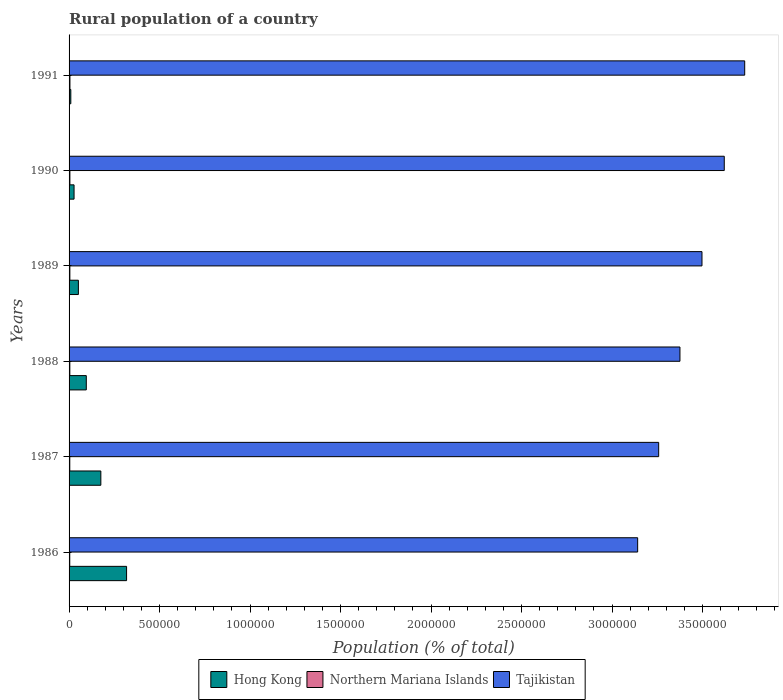Are the number of bars per tick equal to the number of legend labels?
Provide a short and direct response. Yes. How many bars are there on the 4th tick from the top?
Offer a very short reply. 3. How many bars are there on the 6th tick from the bottom?
Your response must be concise. 3. In how many cases, is the number of bars for a given year not equal to the number of legend labels?
Offer a very short reply. 0. What is the rural population in Tajikistan in 1989?
Your answer should be very brief. 3.50e+06. Across all years, what is the maximum rural population in Tajikistan?
Give a very brief answer. 3.73e+06. Across all years, what is the minimum rural population in Hong Kong?
Your answer should be very brief. 9663. In which year was the rural population in Hong Kong minimum?
Your answer should be very brief. 1991. What is the total rural population in Tajikistan in the graph?
Your answer should be very brief. 2.06e+07. What is the difference between the rural population in Tajikistan in 1986 and that in 1988?
Ensure brevity in your answer.  -2.34e+05. What is the difference between the rural population in Northern Mariana Islands in 1990 and the rural population in Tajikistan in 1988?
Your answer should be compact. -3.37e+06. What is the average rural population in Northern Mariana Islands per year?
Your response must be concise. 4250.67. In the year 1989, what is the difference between the rural population in Tajikistan and rural population in Northern Mariana Islands?
Your answer should be very brief. 3.49e+06. What is the ratio of the rural population in Hong Kong in 1988 to that in 1990?
Offer a terse response. 3.45. Is the difference between the rural population in Tajikistan in 1986 and 1987 greater than the difference between the rural population in Northern Mariana Islands in 1986 and 1987?
Your answer should be compact. No. What is the difference between the highest and the second highest rural population in Hong Kong?
Your answer should be compact. 1.42e+05. What is the difference between the highest and the lowest rural population in Northern Mariana Islands?
Your response must be concise. 1057. In how many years, is the rural population in Hong Kong greater than the average rural population in Hong Kong taken over all years?
Provide a succinct answer. 2. Is the sum of the rural population in Hong Kong in 1988 and 1990 greater than the maximum rural population in Tajikistan across all years?
Your answer should be compact. No. What does the 2nd bar from the top in 1989 represents?
Offer a terse response. Northern Mariana Islands. What does the 1st bar from the bottom in 1990 represents?
Your response must be concise. Hong Kong. How many years are there in the graph?
Offer a very short reply. 6. What is the difference between two consecutive major ticks on the X-axis?
Provide a short and direct response. 5.00e+05. Are the values on the major ticks of X-axis written in scientific E-notation?
Keep it short and to the point. No. Does the graph contain any zero values?
Ensure brevity in your answer.  No. Does the graph contain grids?
Your answer should be very brief. No. Where does the legend appear in the graph?
Provide a succinct answer. Bottom center. How are the legend labels stacked?
Ensure brevity in your answer.  Horizontal. What is the title of the graph?
Provide a succinct answer. Rural population of a country. What is the label or title of the X-axis?
Offer a very short reply. Population (% of total). What is the Population (% of total) in Hong Kong in 1986?
Give a very brief answer. 3.18e+05. What is the Population (% of total) of Northern Mariana Islands in 1986?
Your answer should be very brief. 3756. What is the Population (% of total) in Tajikistan in 1986?
Offer a terse response. 3.14e+06. What is the Population (% of total) in Hong Kong in 1987?
Your response must be concise. 1.76e+05. What is the Population (% of total) in Northern Mariana Islands in 1987?
Your response must be concise. 3960. What is the Population (% of total) in Tajikistan in 1987?
Provide a short and direct response. 3.26e+06. What is the Population (% of total) of Hong Kong in 1988?
Make the answer very short. 9.52e+04. What is the Population (% of total) of Northern Mariana Islands in 1988?
Your answer should be compact. 4144. What is the Population (% of total) of Tajikistan in 1988?
Keep it short and to the point. 3.38e+06. What is the Population (% of total) of Hong Kong in 1989?
Provide a short and direct response. 5.15e+04. What is the Population (% of total) in Northern Mariana Islands in 1989?
Give a very brief answer. 4316. What is the Population (% of total) of Tajikistan in 1989?
Keep it short and to the point. 3.50e+06. What is the Population (% of total) in Hong Kong in 1990?
Make the answer very short. 2.76e+04. What is the Population (% of total) of Northern Mariana Islands in 1990?
Provide a short and direct response. 4515. What is the Population (% of total) of Tajikistan in 1990?
Offer a terse response. 3.62e+06. What is the Population (% of total) of Hong Kong in 1991?
Provide a short and direct response. 9663. What is the Population (% of total) of Northern Mariana Islands in 1991?
Give a very brief answer. 4813. What is the Population (% of total) of Tajikistan in 1991?
Offer a terse response. 3.73e+06. Across all years, what is the maximum Population (% of total) in Hong Kong?
Keep it short and to the point. 3.18e+05. Across all years, what is the maximum Population (% of total) of Northern Mariana Islands?
Provide a succinct answer. 4813. Across all years, what is the maximum Population (% of total) in Tajikistan?
Provide a short and direct response. 3.73e+06. Across all years, what is the minimum Population (% of total) of Hong Kong?
Your answer should be very brief. 9663. Across all years, what is the minimum Population (% of total) of Northern Mariana Islands?
Offer a very short reply. 3756. Across all years, what is the minimum Population (% of total) of Tajikistan?
Make the answer very short. 3.14e+06. What is the total Population (% of total) in Hong Kong in the graph?
Make the answer very short. 6.77e+05. What is the total Population (% of total) in Northern Mariana Islands in the graph?
Give a very brief answer. 2.55e+04. What is the total Population (% of total) in Tajikistan in the graph?
Provide a short and direct response. 2.06e+07. What is the difference between the Population (% of total) in Hong Kong in 1986 and that in 1987?
Provide a short and direct response. 1.42e+05. What is the difference between the Population (% of total) of Northern Mariana Islands in 1986 and that in 1987?
Your answer should be very brief. -204. What is the difference between the Population (% of total) in Tajikistan in 1986 and that in 1987?
Ensure brevity in your answer.  -1.16e+05. What is the difference between the Population (% of total) in Hong Kong in 1986 and that in 1988?
Offer a terse response. 2.23e+05. What is the difference between the Population (% of total) in Northern Mariana Islands in 1986 and that in 1988?
Offer a terse response. -388. What is the difference between the Population (% of total) in Tajikistan in 1986 and that in 1988?
Give a very brief answer. -2.34e+05. What is the difference between the Population (% of total) of Hong Kong in 1986 and that in 1989?
Offer a very short reply. 2.66e+05. What is the difference between the Population (% of total) in Northern Mariana Islands in 1986 and that in 1989?
Offer a terse response. -560. What is the difference between the Population (% of total) of Tajikistan in 1986 and that in 1989?
Offer a terse response. -3.55e+05. What is the difference between the Population (% of total) in Hong Kong in 1986 and that in 1990?
Make the answer very short. 2.90e+05. What is the difference between the Population (% of total) of Northern Mariana Islands in 1986 and that in 1990?
Your response must be concise. -759. What is the difference between the Population (% of total) of Tajikistan in 1986 and that in 1990?
Make the answer very short. -4.79e+05. What is the difference between the Population (% of total) in Hong Kong in 1986 and that in 1991?
Keep it short and to the point. 3.08e+05. What is the difference between the Population (% of total) in Northern Mariana Islands in 1986 and that in 1991?
Provide a succinct answer. -1057. What is the difference between the Population (% of total) of Tajikistan in 1986 and that in 1991?
Make the answer very short. -5.92e+05. What is the difference between the Population (% of total) of Hong Kong in 1987 and that in 1988?
Ensure brevity in your answer.  8.04e+04. What is the difference between the Population (% of total) in Northern Mariana Islands in 1987 and that in 1988?
Your response must be concise. -184. What is the difference between the Population (% of total) of Tajikistan in 1987 and that in 1988?
Ensure brevity in your answer.  -1.18e+05. What is the difference between the Population (% of total) in Hong Kong in 1987 and that in 1989?
Make the answer very short. 1.24e+05. What is the difference between the Population (% of total) of Northern Mariana Islands in 1987 and that in 1989?
Your answer should be very brief. -356. What is the difference between the Population (% of total) of Tajikistan in 1987 and that in 1989?
Your answer should be very brief. -2.39e+05. What is the difference between the Population (% of total) in Hong Kong in 1987 and that in 1990?
Make the answer very short. 1.48e+05. What is the difference between the Population (% of total) in Northern Mariana Islands in 1987 and that in 1990?
Make the answer very short. -555. What is the difference between the Population (% of total) of Tajikistan in 1987 and that in 1990?
Make the answer very short. -3.62e+05. What is the difference between the Population (% of total) in Hong Kong in 1987 and that in 1991?
Offer a terse response. 1.66e+05. What is the difference between the Population (% of total) of Northern Mariana Islands in 1987 and that in 1991?
Offer a terse response. -853. What is the difference between the Population (% of total) of Tajikistan in 1987 and that in 1991?
Give a very brief answer. -4.75e+05. What is the difference between the Population (% of total) of Hong Kong in 1988 and that in 1989?
Provide a short and direct response. 4.36e+04. What is the difference between the Population (% of total) of Northern Mariana Islands in 1988 and that in 1989?
Your answer should be compact. -172. What is the difference between the Population (% of total) in Tajikistan in 1988 and that in 1989?
Provide a succinct answer. -1.22e+05. What is the difference between the Population (% of total) of Hong Kong in 1988 and that in 1990?
Offer a terse response. 6.76e+04. What is the difference between the Population (% of total) in Northern Mariana Islands in 1988 and that in 1990?
Provide a succinct answer. -371. What is the difference between the Population (% of total) in Tajikistan in 1988 and that in 1990?
Your response must be concise. -2.45e+05. What is the difference between the Population (% of total) in Hong Kong in 1988 and that in 1991?
Provide a short and direct response. 8.55e+04. What is the difference between the Population (% of total) of Northern Mariana Islands in 1988 and that in 1991?
Offer a terse response. -669. What is the difference between the Population (% of total) of Tajikistan in 1988 and that in 1991?
Ensure brevity in your answer.  -3.58e+05. What is the difference between the Population (% of total) of Hong Kong in 1989 and that in 1990?
Give a very brief answer. 2.40e+04. What is the difference between the Population (% of total) of Northern Mariana Islands in 1989 and that in 1990?
Provide a succinct answer. -199. What is the difference between the Population (% of total) of Tajikistan in 1989 and that in 1990?
Offer a very short reply. -1.23e+05. What is the difference between the Population (% of total) in Hong Kong in 1989 and that in 1991?
Offer a terse response. 4.19e+04. What is the difference between the Population (% of total) in Northern Mariana Islands in 1989 and that in 1991?
Ensure brevity in your answer.  -497. What is the difference between the Population (% of total) in Tajikistan in 1989 and that in 1991?
Make the answer very short. -2.36e+05. What is the difference between the Population (% of total) in Hong Kong in 1990 and that in 1991?
Provide a short and direct response. 1.79e+04. What is the difference between the Population (% of total) of Northern Mariana Islands in 1990 and that in 1991?
Your answer should be very brief. -298. What is the difference between the Population (% of total) of Tajikistan in 1990 and that in 1991?
Keep it short and to the point. -1.13e+05. What is the difference between the Population (% of total) in Hong Kong in 1986 and the Population (% of total) in Northern Mariana Islands in 1987?
Keep it short and to the point. 3.14e+05. What is the difference between the Population (% of total) of Hong Kong in 1986 and the Population (% of total) of Tajikistan in 1987?
Keep it short and to the point. -2.94e+06. What is the difference between the Population (% of total) in Northern Mariana Islands in 1986 and the Population (% of total) in Tajikistan in 1987?
Your response must be concise. -3.25e+06. What is the difference between the Population (% of total) in Hong Kong in 1986 and the Population (% of total) in Northern Mariana Islands in 1988?
Ensure brevity in your answer.  3.14e+05. What is the difference between the Population (% of total) in Hong Kong in 1986 and the Population (% of total) in Tajikistan in 1988?
Keep it short and to the point. -3.06e+06. What is the difference between the Population (% of total) in Northern Mariana Islands in 1986 and the Population (% of total) in Tajikistan in 1988?
Your response must be concise. -3.37e+06. What is the difference between the Population (% of total) in Hong Kong in 1986 and the Population (% of total) in Northern Mariana Islands in 1989?
Offer a terse response. 3.13e+05. What is the difference between the Population (% of total) of Hong Kong in 1986 and the Population (% of total) of Tajikistan in 1989?
Ensure brevity in your answer.  -3.18e+06. What is the difference between the Population (% of total) of Northern Mariana Islands in 1986 and the Population (% of total) of Tajikistan in 1989?
Keep it short and to the point. -3.49e+06. What is the difference between the Population (% of total) in Hong Kong in 1986 and the Population (% of total) in Northern Mariana Islands in 1990?
Your answer should be compact. 3.13e+05. What is the difference between the Population (% of total) in Hong Kong in 1986 and the Population (% of total) in Tajikistan in 1990?
Your response must be concise. -3.30e+06. What is the difference between the Population (% of total) in Northern Mariana Islands in 1986 and the Population (% of total) in Tajikistan in 1990?
Offer a very short reply. -3.62e+06. What is the difference between the Population (% of total) in Hong Kong in 1986 and the Population (% of total) in Northern Mariana Islands in 1991?
Make the answer very short. 3.13e+05. What is the difference between the Population (% of total) of Hong Kong in 1986 and the Population (% of total) of Tajikistan in 1991?
Your answer should be compact. -3.42e+06. What is the difference between the Population (% of total) of Northern Mariana Islands in 1986 and the Population (% of total) of Tajikistan in 1991?
Offer a terse response. -3.73e+06. What is the difference between the Population (% of total) in Hong Kong in 1987 and the Population (% of total) in Northern Mariana Islands in 1988?
Offer a very short reply. 1.71e+05. What is the difference between the Population (% of total) in Hong Kong in 1987 and the Population (% of total) in Tajikistan in 1988?
Your answer should be compact. -3.20e+06. What is the difference between the Population (% of total) in Northern Mariana Islands in 1987 and the Population (% of total) in Tajikistan in 1988?
Your response must be concise. -3.37e+06. What is the difference between the Population (% of total) in Hong Kong in 1987 and the Population (% of total) in Northern Mariana Islands in 1989?
Provide a short and direct response. 1.71e+05. What is the difference between the Population (% of total) in Hong Kong in 1987 and the Population (% of total) in Tajikistan in 1989?
Provide a succinct answer. -3.32e+06. What is the difference between the Population (% of total) of Northern Mariana Islands in 1987 and the Population (% of total) of Tajikistan in 1989?
Your answer should be compact. -3.49e+06. What is the difference between the Population (% of total) of Hong Kong in 1987 and the Population (% of total) of Northern Mariana Islands in 1990?
Provide a succinct answer. 1.71e+05. What is the difference between the Population (% of total) in Hong Kong in 1987 and the Population (% of total) in Tajikistan in 1990?
Your answer should be compact. -3.44e+06. What is the difference between the Population (% of total) in Northern Mariana Islands in 1987 and the Population (% of total) in Tajikistan in 1990?
Offer a terse response. -3.62e+06. What is the difference between the Population (% of total) of Hong Kong in 1987 and the Population (% of total) of Northern Mariana Islands in 1991?
Your response must be concise. 1.71e+05. What is the difference between the Population (% of total) of Hong Kong in 1987 and the Population (% of total) of Tajikistan in 1991?
Your answer should be compact. -3.56e+06. What is the difference between the Population (% of total) in Northern Mariana Islands in 1987 and the Population (% of total) in Tajikistan in 1991?
Give a very brief answer. -3.73e+06. What is the difference between the Population (% of total) of Hong Kong in 1988 and the Population (% of total) of Northern Mariana Islands in 1989?
Ensure brevity in your answer.  9.08e+04. What is the difference between the Population (% of total) in Hong Kong in 1988 and the Population (% of total) in Tajikistan in 1989?
Make the answer very short. -3.40e+06. What is the difference between the Population (% of total) in Northern Mariana Islands in 1988 and the Population (% of total) in Tajikistan in 1989?
Keep it short and to the point. -3.49e+06. What is the difference between the Population (% of total) in Hong Kong in 1988 and the Population (% of total) in Northern Mariana Islands in 1990?
Provide a succinct answer. 9.06e+04. What is the difference between the Population (% of total) of Hong Kong in 1988 and the Population (% of total) of Tajikistan in 1990?
Keep it short and to the point. -3.53e+06. What is the difference between the Population (% of total) of Northern Mariana Islands in 1988 and the Population (% of total) of Tajikistan in 1990?
Your answer should be very brief. -3.62e+06. What is the difference between the Population (% of total) of Hong Kong in 1988 and the Population (% of total) of Northern Mariana Islands in 1991?
Your answer should be compact. 9.04e+04. What is the difference between the Population (% of total) of Hong Kong in 1988 and the Population (% of total) of Tajikistan in 1991?
Keep it short and to the point. -3.64e+06. What is the difference between the Population (% of total) in Northern Mariana Islands in 1988 and the Population (% of total) in Tajikistan in 1991?
Keep it short and to the point. -3.73e+06. What is the difference between the Population (% of total) in Hong Kong in 1989 and the Population (% of total) in Northern Mariana Islands in 1990?
Provide a succinct answer. 4.70e+04. What is the difference between the Population (% of total) of Hong Kong in 1989 and the Population (% of total) of Tajikistan in 1990?
Keep it short and to the point. -3.57e+06. What is the difference between the Population (% of total) in Northern Mariana Islands in 1989 and the Population (% of total) in Tajikistan in 1990?
Ensure brevity in your answer.  -3.62e+06. What is the difference between the Population (% of total) of Hong Kong in 1989 and the Population (% of total) of Northern Mariana Islands in 1991?
Your response must be concise. 4.67e+04. What is the difference between the Population (% of total) in Hong Kong in 1989 and the Population (% of total) in Tajikistan in 1991?
Your answer should be very brief. -3.68e+06. What is the difference between the Population (% of total) of Northern Mariana Islands in 1989 and the Population (% of total) of Tajikistan in 1991?
Provide a short and direct response. -3.73e+06. What is the difference between the Population (% of total) in Hong Kong in 1990 and the Population (% of total) in Northern Mariana Islands in 1991?
Your response must be concise. 2.27e+04. What is the difference between the Population (% of total) of Hong Kong in 1990 and the Population (% of total) of Tajikistan in 1991?
Give a very brief answer. -3.71e+06. What is the difference between the Population (% of total) of Northern Mariana Islands in 1990 and the Population (% of total) of Tajikistan in 1991?
Keep it short and to the point. -3.73e+06. What is the average Population (% of total) in Hong Kong per year?
Offer a very short reply. 1.13e+05. What is the average Population (% of total) in Northern Mariana Islands per year?
Offer a terse response. 4250.67. What is the average Population (% of total) of Tajikistan per year?
Ensure brevity in your answer.  3.44e+06. In the year 1986, what is the difference between the Population (% of total) of Hong Kong and Population (% of total) of Northern Mariana Islands?
Make the answer very short. 3.14e+05. In the year 1986, what is the difference between the Population (% of total) of Hong Kong and Population (% of total) of Tajikistan?
Ensure brevity in your answer.  -2.82e+06. In the year 1986, what is the difference between the Population (% of total) in Northern Mariana Islands and Population (% of total) in Tajikistan?
Offer a very short reply. -3.14e+06. In the year 1987, what is the difference between the Population (% of total) of Hong Kong and Population (% of total) of Northern Mariana Islands?
Your response must be concise. 1.72e+05. In the year 1987, what is the difference between the Population (% of total) in Hong Kong and Population (% of total) in Tajikistan?
Provide a short and direct response. -3.08e+06. In the year 1987, what is the difference between the Population (% of total) of Northern Mariana Islands and Population (% of total) of Tajikistan?
Offer a very short reply. -3.25e+06. In the year 1988, what is the difference between the Population (% of total) of Hong Kong and Population (% of total) of Northern Mariana Islands?
Ensure brevity in your answer.  9.10e+04. In the year 1988, what is the difference between the Population (% of total) of Hong Kong and Population (% of total) of Tajikistan?
Offer a terse response. -3.28e+06. In the year 1988, what is the difference between the Population (% of total) in Northern Mariana Islands and Population (% of total) in Tajikistan?
Your response must be concise. -3.37e+06. In the year 1989, what is the difference between the Population (% of total) of Hong Kong and Population (% of total) of Northern Mariana Islands?
Offer a very short reply. 4.72e+04. In the year 1989, what is the difference between the Population (% of total) in Hong Kong and Population (% of total) in Tajikistan?
Your response must be concise. -3.45e+06. In the year 1989, what is the difference between the Population (% of total) of Northern Mariana Islands and Population (% of total) of Tajikistan?
Provide a short and direct response. -3.49e+06. In the year 1990, what is the difference between the Population (% of total) in Hong Kong and Population (% of total) in Northern Mariana Islands?
Keep it short and to the point. 2.30e+04. In the year 1990, what is the difference between the Population (% of total) in Hong Kong and Population (% of total) in Tajikistan?
Your response must be concise. -3.59e+06. In the year 1990, what is the difference between the Population (% of total) in Northern Mariana Islands and Population (% of total) in Tajikistan?
Your answer should be compact. -3.62e+06. In the year 1991, what is the difference between the Population (% of total) in Hong Kong and Population (% of total) in Northern Mariana Islands?
Offer a very short reply. 4850. In the year 1991, what is the difference between the Population (% of total) of Hong Kong and Population (% of total) of Tajikistan?
Give a very brief answer. -3.72e+06. In the year 1991, what is the difference between the Population (% of total) of Northern Mariana Islands and Population (% of total) of Tajikistan?
Provide a short and direct response. -3.73e+06. What is the ratio of the Population (% of total) in Hong Kong in 1986 to that in 1987?
Your answer should be compact. 1.81. What is the ratio of the Population (% of total) in Northern Mariana Islands in 1986 to that in 1987?
Provide a succinct answer. 0.95. What is the ratio of the Population (% of total) of Tajikistan in 1986 to that in 1987?
Keep it short and to the point. 0.96. What is the ratio of the Population (% of total) of Hong Kong in 1986 to that in 1988?
Keep it short and to the point. 3.34. What is the ratio of the Population (% of total) of Northern Mariana Islands in 1986 to that in 1988?
Offer a very short reply. 0.91. What is the ratio of the Population (% of total) in Tajikistan in 1986 to that in 1988?
Ensure brevity in your answer.  0.93. What is the ratio of the Population (% of total) of Hong Kong in 1986 to that in 1989?
Offer a very short reply. 6.17. What is the ratio of the Population (% of total) of Northern Mariana Islands in 1986 to that in 1989?
Offer a terse response. 0.87. What is the ratio of the Population (% of total) in Tajikistan in 1986 to that in 1989?
Your response must be concise. 0.9. What is the ratio of the Population (% of total) of Hong Kong in 1986 to that in 1990?
Keep it short and to the point. 11.53. What is the ratio of the Population (% of total) of Northern Mariana Islands in 1986 to that in 1990?
Keep it short and to the point. 0.83. What is the ratio of the Population (% of total) in Tajikistan in 1986 to that in 1990?
Provide a succinct answer. 0.87. What is the ratio of the Population (% of total) in Hong Kong in 1986 to that in 1991?
Offer a very short reply. 32.89. What is the ratio of the Population (% of total) of Northern Mariana Islands in 1986 to that in 1991?
Make the answer very short. 0.78. What is the ratio of the Population (% of total) in Tajikistan in 1986 to that in 1991?
Provide a short and direct response. 0.84. What is the ratio of the Population (% of total) of Hong Kong in 1987 to that in 1988?
Provide a short and direct response. 1.84. What is the ratio of the Population (% of total) of Northern Mariana Islands in 1987 to that in 1988?
Provide a short and direct response. 0.96. What is the ratio of the Population (% of total) in Tajikistan in 1987 to that in 1988?
Ensure brevity in your answer.  0.97. What is the ratio of the Population (% of total) in Hong Kong in 1987 to that in 1989?
Keep it short and to the point. 3.41. What is the ratio of the Population (% of total) in Northern Mariana Islands in 1987 to that in 1989?
Offer a terse response. 0.92. What is the ratio of the Population (% of total) of Tajikistan in 1987 to that in 1989?
Provide a short and direct response. 0.93. What is the ratio of the Population (% of total) in Hong Kong in 1987 to that in 1990?
Keep it short and to the point. 6.37. What is the ratio of the Population (% of total) in Northern Mariana Islands in 1987 to that in 1990?
Ensure brevity in your answer.  0.88. What is the ratio of the Population (% of total) of Tajikistan in 1987 to that in 1990?
Give a very brief answer. 0.9. What is the ratio of the Population (% of total) of Hong Kong in 1987 to that in 1991?
Your answer should be very brief. 18.17. What is the ratio of the Population (% of total) of Northern Mariana Islands in 1987 to that in 1991?
Offer a terse response. 0.82. What is the ratio of the Population (% of total) of Tajikistan in 1987 to that in 1991?
Make the answer very short. 0.87. What is the ratio of the Population (% of total) in Hong Kong in 1988 to that in 1989?
Give a very brief answer. 1.85. What is the ratio of the Population (% of total) of Northern Mariana Islands in 1988 to that in 1989?
Offer a very short reply. 0.96. What is the ratio of the Population (% of total) of Tajikistan in 1988 to that in 1989?
Your response must be concise. 0.97. What is the ratio of the Population (% of total) in Hong Kong in 1988 to that in 1990?
Your answer should be compact. 3.45. What is the ratio of the Population (% of total) of Northern Mariana Islands in 1988 to that in 1990?
Ensure brevity in your answer.  0.92. What is the ratio of the Population (% of total) in Tajikistan in 1988 to that in 1990?
Keep it short and to the point. 0.93. What is the ratio of the Population (% of total) of Hong Kong in 1988 to that in 1991?
Provide a short and direct response. 9.85. What is the ratio of the Population (% of total) in Northern Mariana Islands in 1988 to that in 1991?
Keep it short and to the point. 0.86. What is the ratio of the Population (% of total) in Tajikistan in 1988 to that in 1991?
Your answer should be compact. 0.9. What is the ratio of the Population (% of total) in Hong Kong in 1989 to that in 1990?
Your response must be concise. 1.87. What is the ratio of the Population (% of total) in Northern Mariana Islands in 1989 to that in 1990?
Ensure brevity in your answer.  0.96. What is the ratio of the Population (% of total) in Hong Kong in 1989 to that in 1991?
Offer a very short reply. 5.33. What is the ratio of the Population (% of total) in Northern Mariana Islands in 1989 to that in 1991?
Provide a succinct answer. 0.9. What is the ratio of the Population (% of total) of Tajikistan in 1989 to that in 1991?
Provide a succinct answer. 0.94. What is the ratio of the Population (% of total) of Hong Kong in 1990 to that in 1991?
Your response must be concise. 2.85. What is the ratio of the Population (% of total) of Northern Mariana Islands in 1990 to that in 1991?
Keep it short and to the point. 0.94. What is the ratio of the Population (% of total) in Tajikistan in 1990 to that in 1991?
Keep it short and to the point. 0.97. What is the difference between the highest and the second highest Population (% of total) in Hong Kong?
Provide a succinct answer. 1.42e+05. What is the difference between the highest and the second highest Population (% of total) in Northern Mariana Islands?
Offer a very short reply. 298. What is the difference between the highest and the second highest Population (% of total) of Tajikistan?
Your answer should be very brief. 1.13e+05. What is the difference between the highest and the lowest Population (% of total) of Hong Kong?
Offer a terse response. 3.08e+05. What is the difference between the highest and the lowest Population (% of total) of Northern Mariana Islands?
Give a very brief answer. 1057. What is the difference between the highest and the lowest Population (% of total) in Tajikistan?
Your answer should be compact. 5.92e+05. 